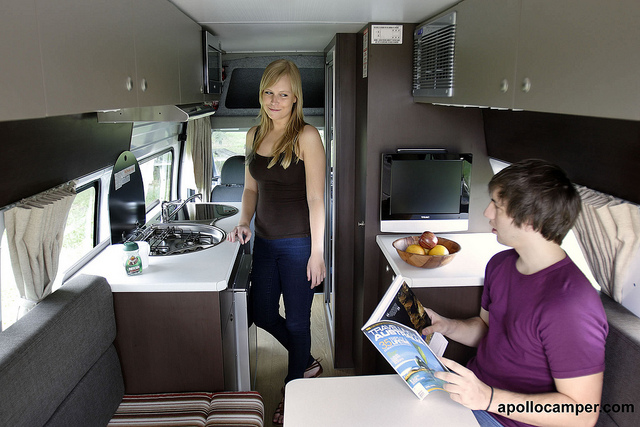Read all the text in this image. apollocamper.com 35 